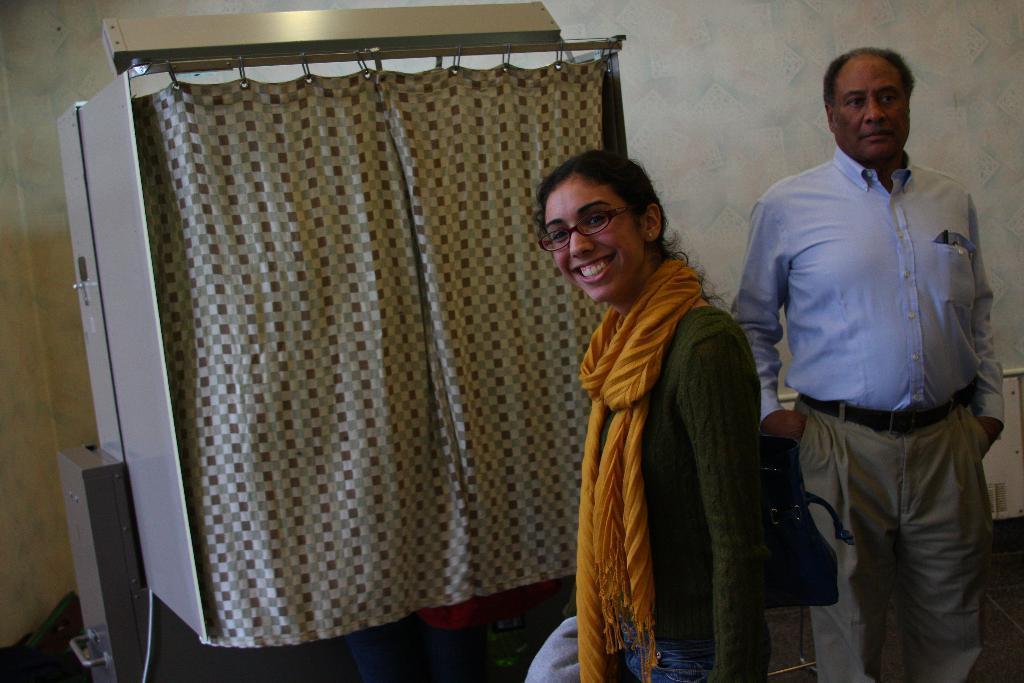In one or two sentences, can you explain what this image depicts? In this picture there is a women wearing green dress is carrying a handbag and smiling and there is a machine which has a curtain attached to it beside her and there is a person standing in the right corner. 